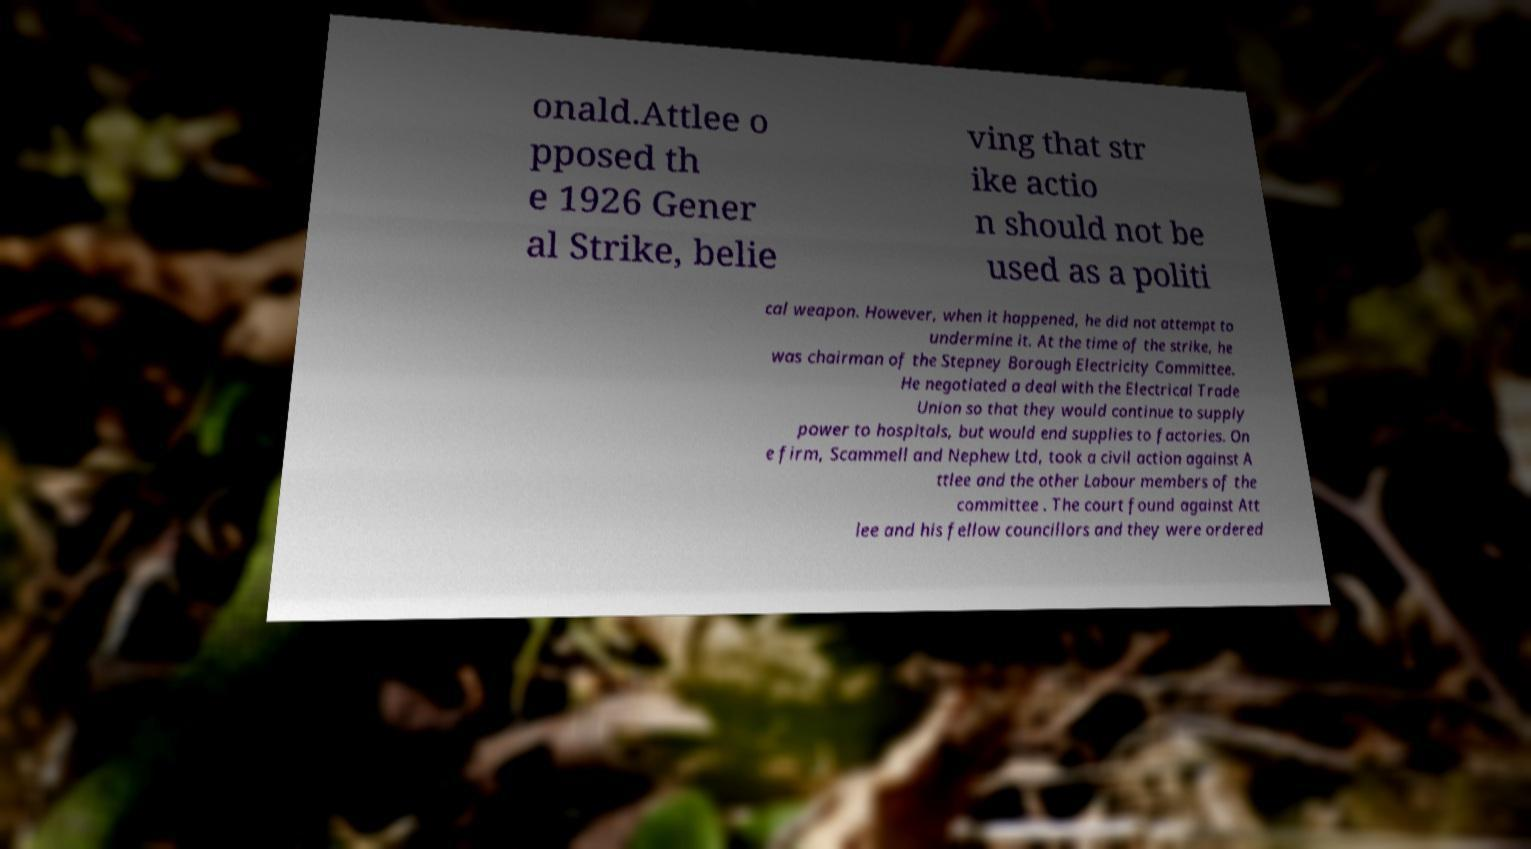Could you assist in decoding the text presented in this image and type it out clearly? onald.Attlee o pposed th e 1926 Gener al Strike, belie ving that str ike actio n should not be used as a politi cal weapon. However, when it happened, he did not attempt to undermine it. At the time of the strike, he was chairman of the Stepney Borough Electricity Committee. He negotiated a deal with the Electrical Trade Union so that they would continue to supply power to hospitals, but would end supplies to factories. On e firm, Scammell and Nephew Ltd, took a civil action against A ttlee and the other Labour members of the committee . The court found against Att lee and his fellow councillors and they were ordered 